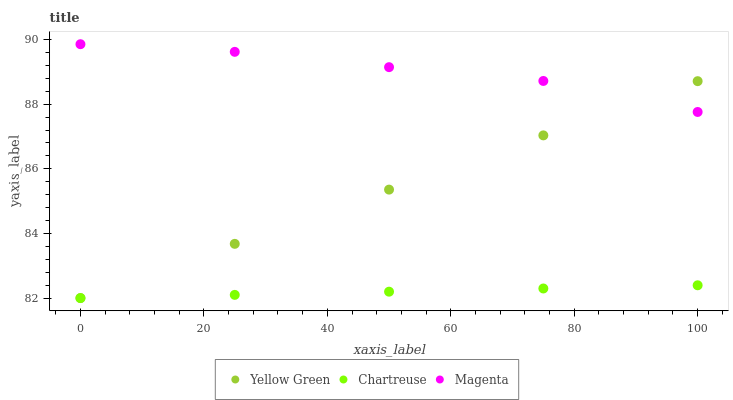Does Chartreuse have the minimum area under the curve?
Answer yes or no. Yes. Does Magenta have the maximum area under the curve?
Answer yes or no. Yes. Does Yellow Green have the minimum area under the curve?
Answer yes or no. No. Does Yellow Green have the maximum area under the curve?
Answer yes or no. No. Is Yellow Green the smoothest?
Answer yes or no. Yes. Is Magenta the roughest?
Answer yes or no. Yes. Is Magenta the smoothest?
Answer yes or no. No. Is Yellow Green the roughest?
Answer yes or no. No. Does Chartreuse have the lowest value?
Answer yes or no. Yes. Does Magenta have the lowest value?
Answer yes or no. No. Does Magenta have the highest value?
Answer yes or no. Yes. Does Yellow Green have the highest value?
Answer yes or no. No. Is Chartreuse less than Magenta?
Answer yes or no. Yes. Is Magenta greater than Chartreuse?
Answer yes or no. Yes. Does Yellow Green intersect Chartreuse?
Answer yes or no. Yes. Is Yellow Green less than Chartreuse?
Answer yes or no. No. Is Yellow Green greater than Chartreuse?
Answer yes or no. No. Does Chartreuse intersect Magenta?
Answer yes or no. No. 